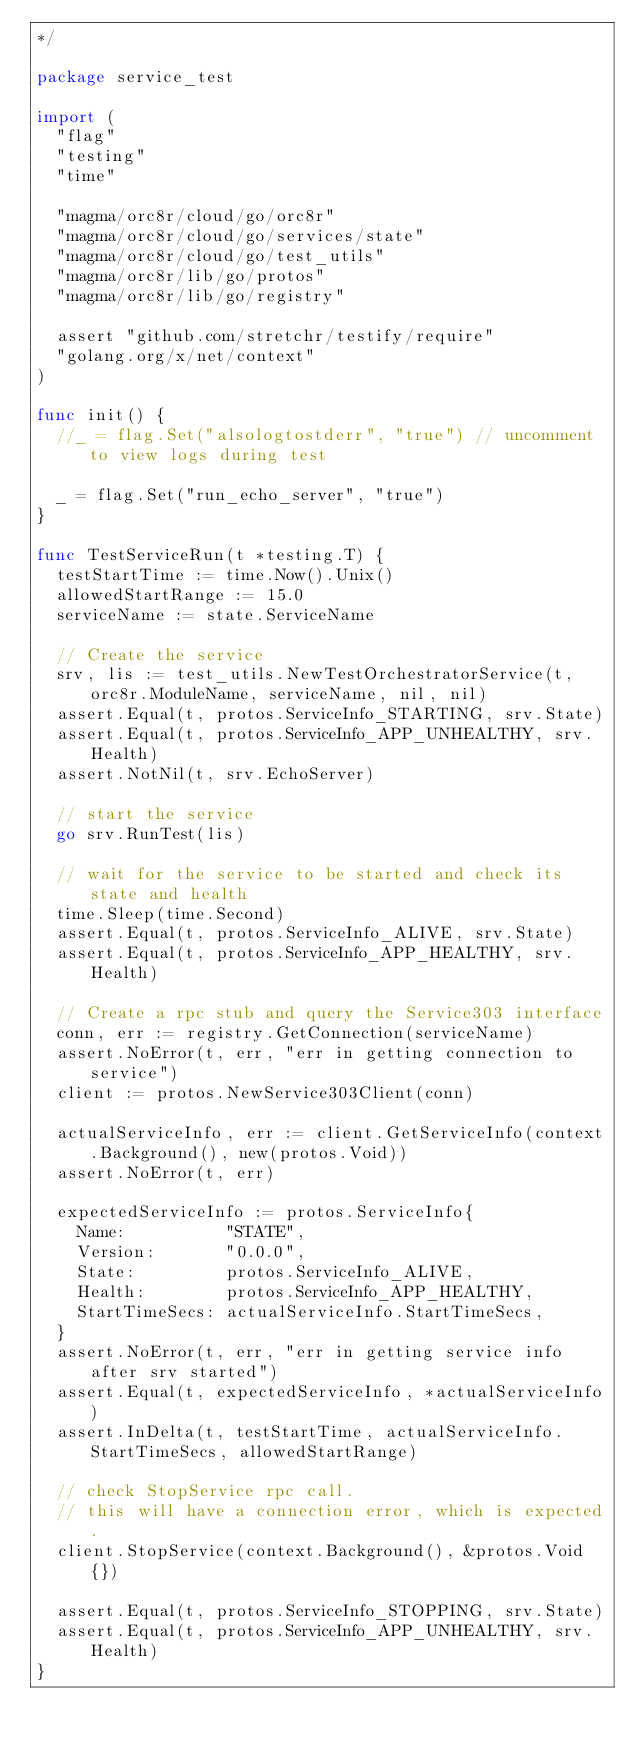Convert code to text. <code><loc_0><loc_0><loc_500><loc_500><_Go_>*/

package service_test

import (
	"flag"
	"testing"
	"time"

	"magma/orc8r/cloud/go/orc8r"
	"magma/orc8r/cloud/go/services/state"
	"magma/orc8r/cloud/go/test_utils"
	"magma/orc8r/lib/go/protos"
	"magma/orc8r/lib/go/registry"

	assert "github.com/stretchr/testify/require"
	"golang.org/x/net/context"
)

func init() {
	//_ = flag.Set("alsologtostderr", "true") // uncomment to view logs during test

	_ = flag.Set("run_echo_server", "true")
}

func TestServiceRun(t *testing.T) {
	testStartTime := time.Now().Unix()
	allowedStartRange := 15.0
	serviceName := state.ServiceName

	// Create the service
	srv, lis := test_utils.NewTestOrchestratorService(t, orc8r.ModuleName, serviceName, nil, nil)
	assert.Equal(t, protos.ServiceInfo_STARTING, srv.State)
	assert.Equal(t, protos.ServiceInfo_APP_UNHEALTHY, srv.Health)
	assert.NotNil(t, srv.EchoServer)

	// start the service
	go srv.RunTest(lis)

	// wait for the service to be started and check its state and health
	time.Sleep(time.Second)
	assert.Equal(t, protos.ServiceInfo_ALIVE, srv.State)
	assert.Equal(t, protos.ServiceInfo_APP_HEALTHY, srv.Health)

	// Create a rpc stub and query the Service303 interface
	conn, err := registry.GetConnection(serviceName)
	assert.NoError(t, err, "err in getting connection to service")
	client := protos.NewService303Client(conn)

	actualServiceInfo, err := client.GetServiceInfo(context.Background(), new(protos.Void))
	assert.NoError(t, err)

	expectedServiceInfo := protos.ServiceInfo{
		Name:          "STATE",
		Version:       "0.0.0",
		State:         protos.ServiceInfo_ALIVE,
		Health:        protos.ServiceInfo_APP_HEALTHY,
		StartTimeSecs: actualServiceInfo.StartTimeSecs,
	}
	assert.NoError(t, err, "err in getting service info after srv started")
	assert.Equal(t, expectedServiceInfo, *actualServiceInfo)
	assert.InDelta(t, testStartTime, actualServiceInfo.StartTimeSecs, allowedStartRange)

	// check StopService rpc call.
	// this will have a connection error, which is expected.
	client.StopService(context.Background(), &protos.Void{})

	assert.Equal(t, protos.ServiceInfo_STOPPING, srv.State)
	assert.Equal(t, protos.ServiceInfo_APP_UNHEALTHY, srv.Health)
}
</code> 